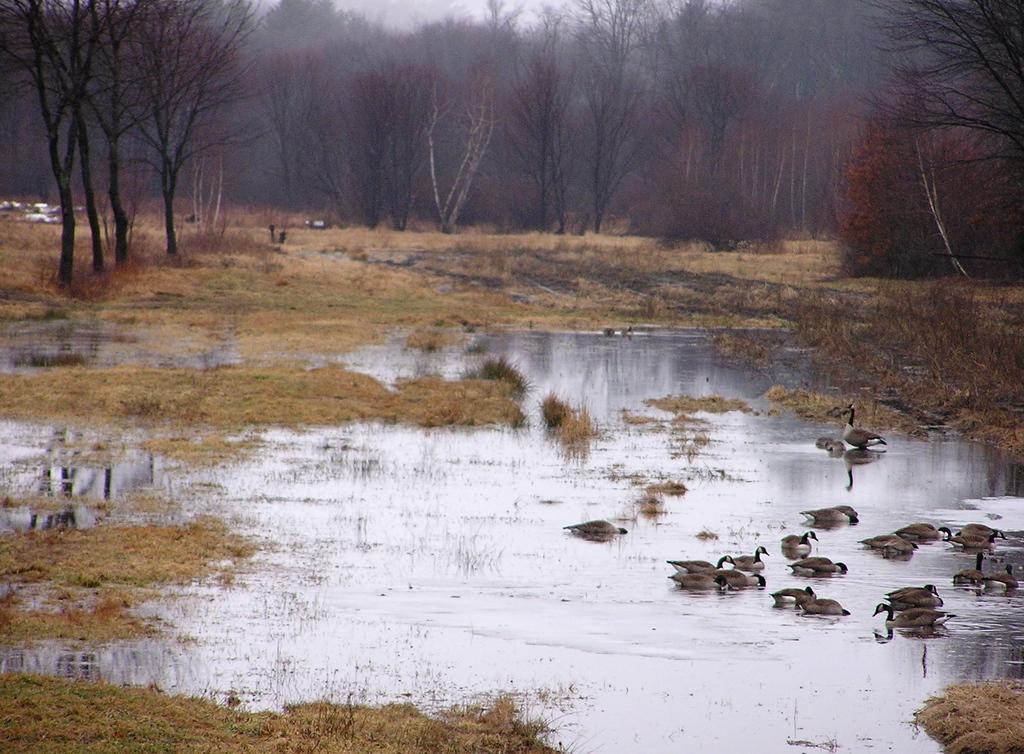Please provide a concise description of this image. In this image we can see the birds on the surface of the water. We can also see the grass, trees and also the sky. 